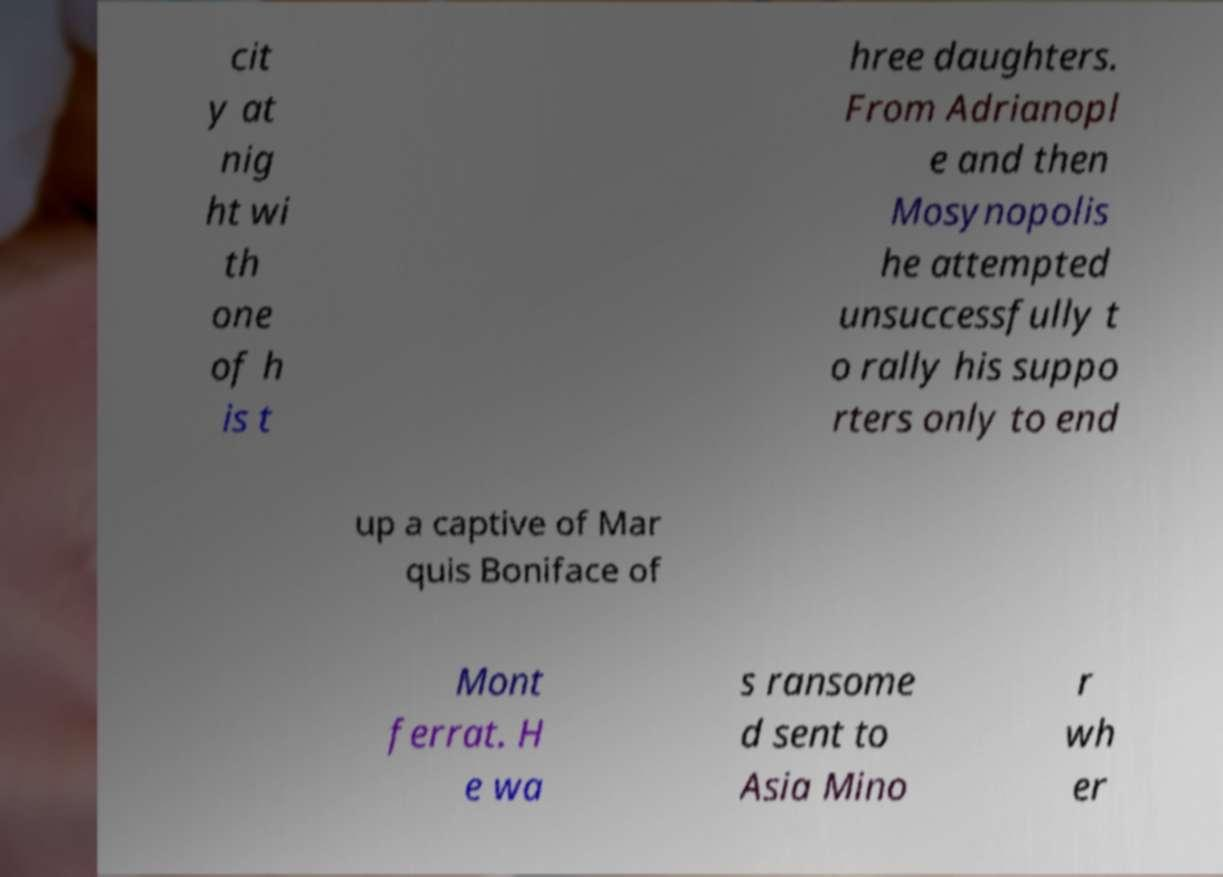Please read and relay the text visible in this image. What does it say? cit y at nig ht wi th one of h is t hree daughters. From Adrianopl e and then Mosynopolis he attempted unsuccessfully t o rally his suppo rters only to end up a captive of Mar quis Boniface of Mont ferrat. H e wa s ransome d sent to Asia Mino r wh er 